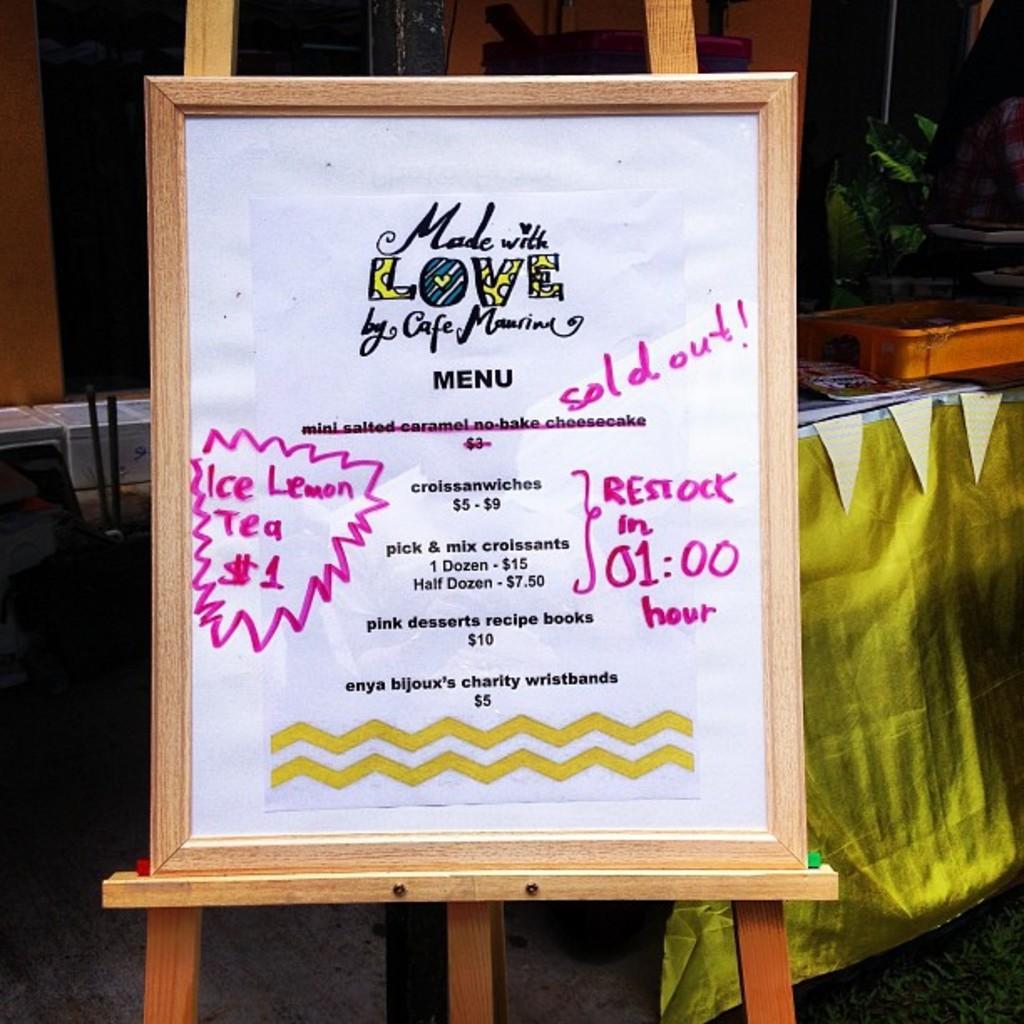Please provide a concise description of this image. In this image we can see a photo frame, there is some matter written on it, at the back there is a table, there is a container and some objects on it, there is a curtain. 